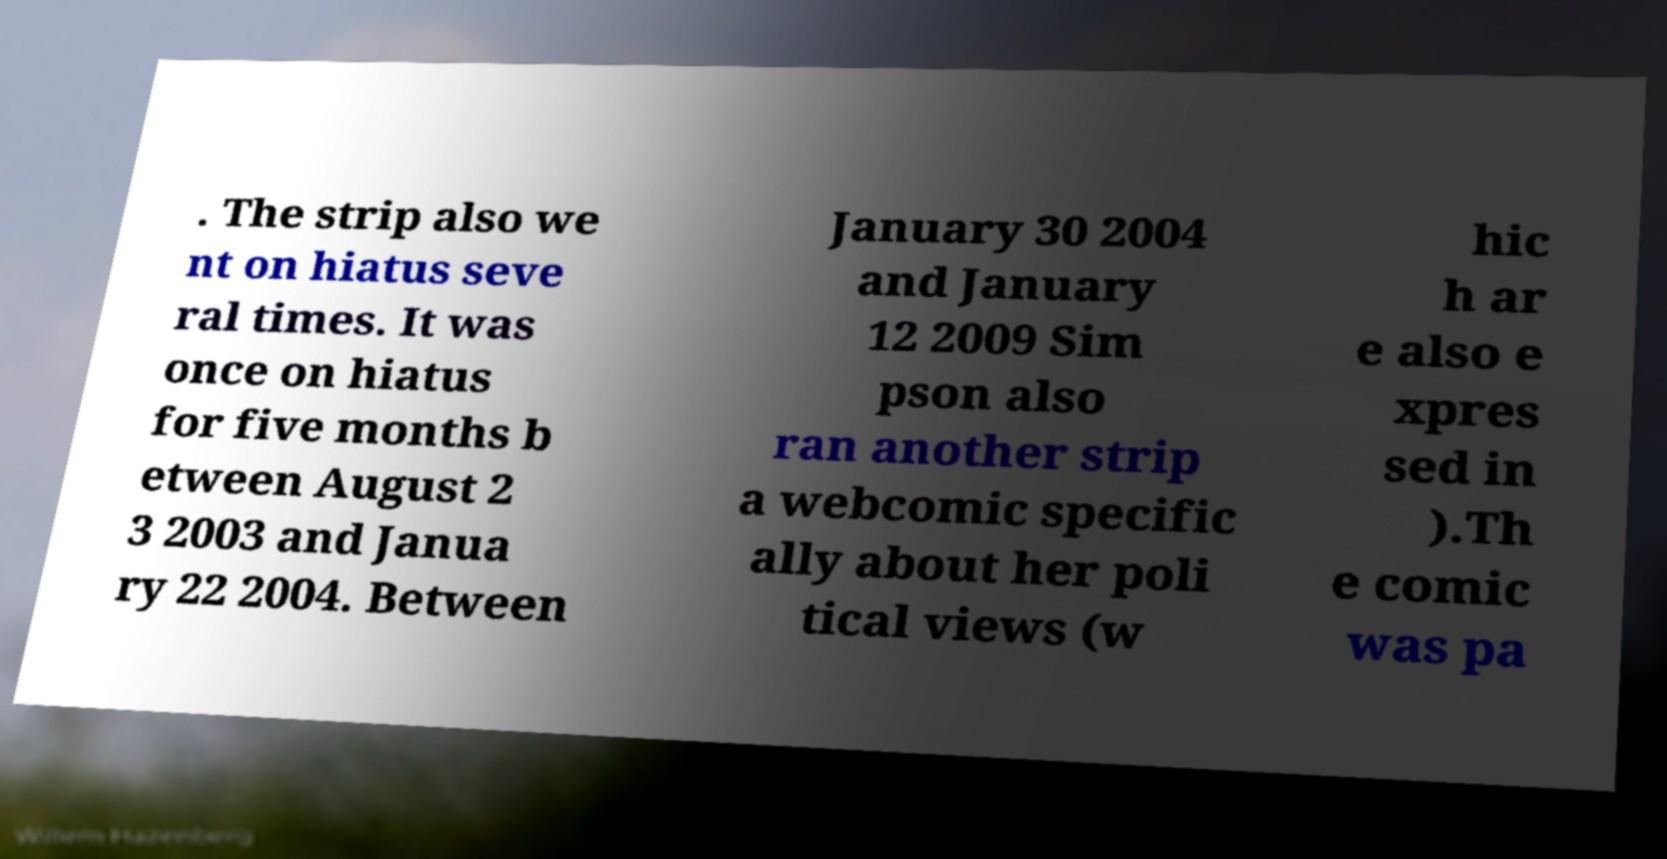What messages or text are displayed in this image? I need them in a readable, typed format. . The strip also we nt on hiatus seve ral times. It was once on hiatus for five months b etween August 2 3 2003 and Janua ry 22 2004. Between January 30 2004 and January 12 2009 Sim pson also ran another strip a webcomic specific ally about her poli tical views (w hic h ar e also e xpres sed in ).Th e comic was pa 